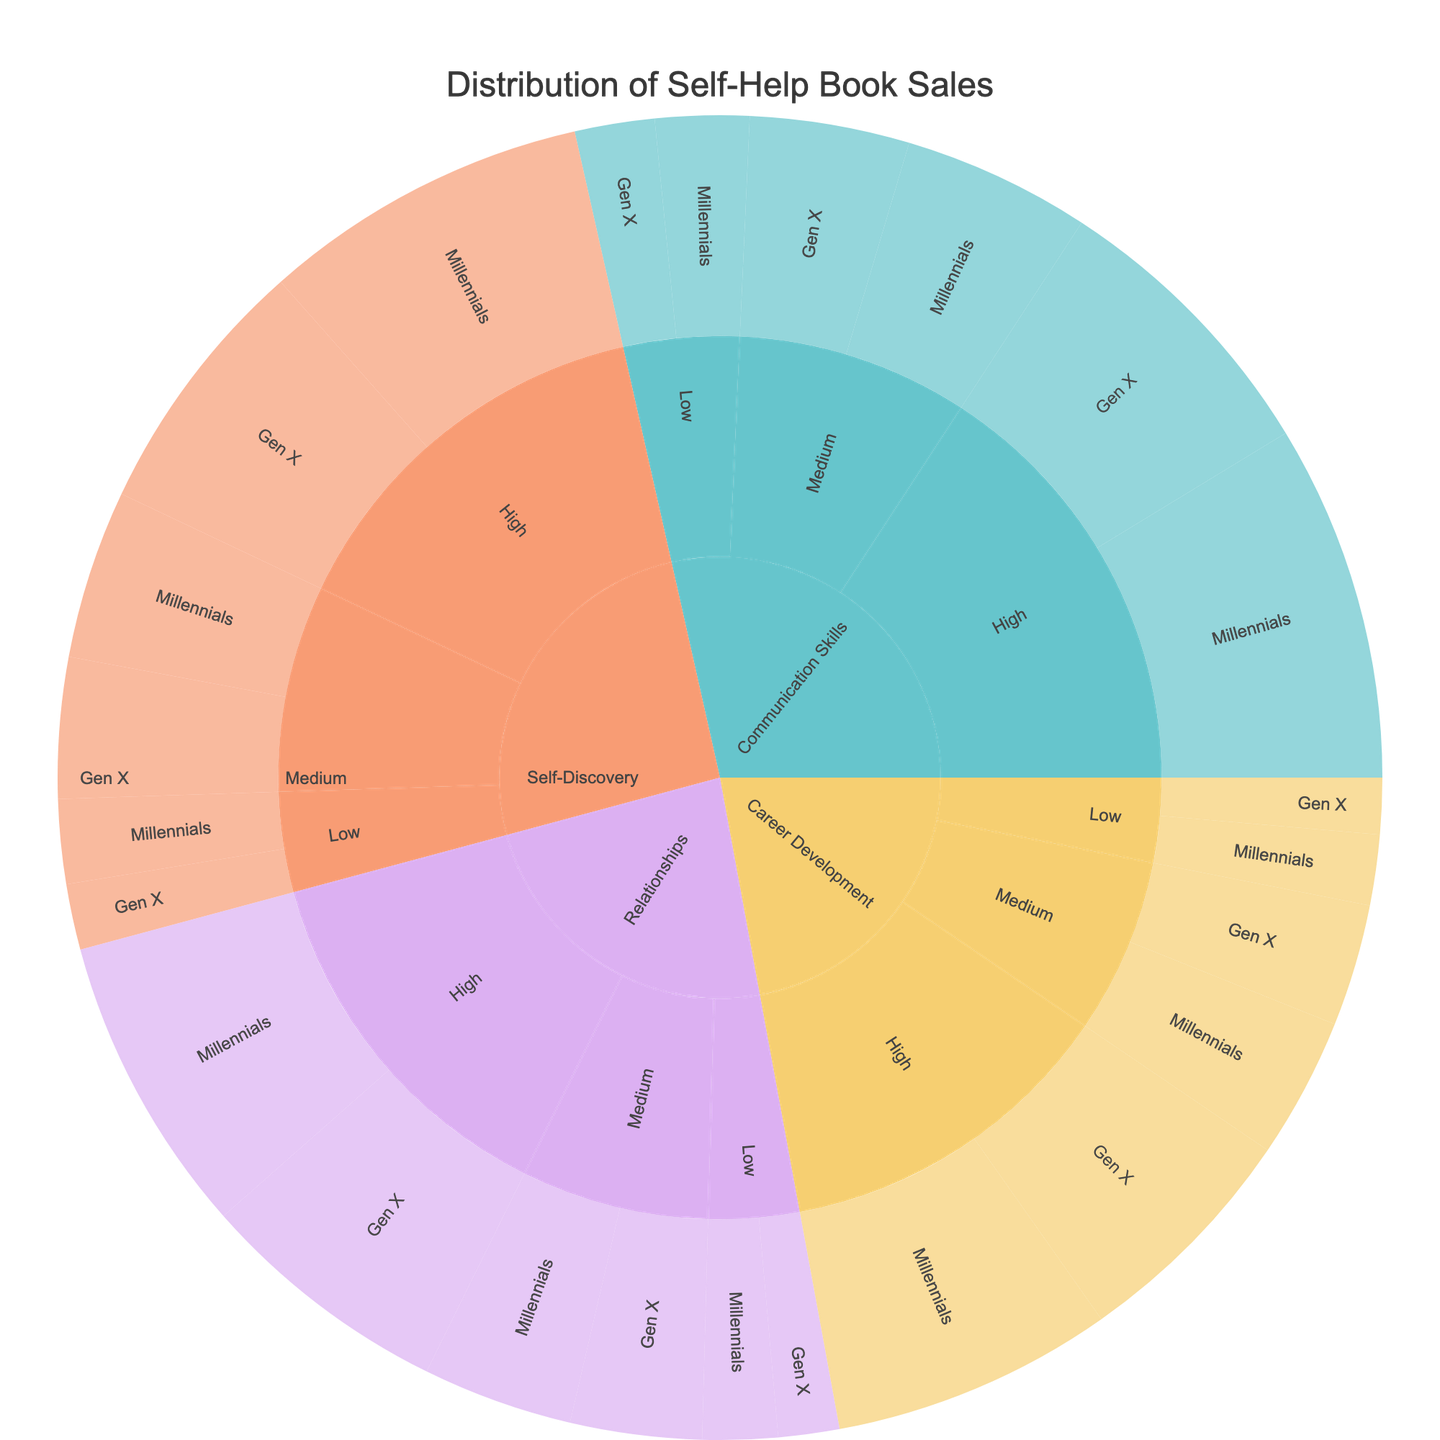what is the genre with the highest sales for Millennials? To identify the genre with the highest sales for Millennials, locate the most extensive segment within each genre and filter by the target audience, which are Millennials. Then, compare the total sales for each genre aimed at Millennials. The largest segment with the highest value will indicate the highest sales.
Answer: Communication Skills How do sales in the Career Development genre compare between High and Medium popularity authors for Gen X? In the Career Development genre, check the segments for High and Medium popularity authors targeting Gen X. Sum the sales for High popularity authors (250,000) and for Medium popularity authors (130,000), and then compare these two sums to determine the difference.
Answer: 120,000 more for High What proportion of total sales does Self-Discovery generate for Gen X? Sum the sales of Self-Discovery books targeting Gen X, which is 280,000 (High authors) + 150,000 (Medium authors) + 70,000 (Low authors) = 500,000. Divide this by the total sales for the entire dataset, calculated across all segments. The dataset's total sales are 4,935,000, deriving proportion as 500,000/4,935,000.
Answer: 10.13% Which target audience has higher sales for Low popularity authors in the Relationships genre, Millennials or Gen X? Compare the sales of Low popularity authors in the Relationships genre segmented by target audience. For Millennials, it's 80,000, and for Gen X, it's 65,000. Determine which number is higher.
Answer: Millennials In which genre do Medium popularity authors receive the lowest sales from Millennials? Examine each genre and target the segment for Medium popularity authors aimed at Millennials. Compare the sales figures across these segments: Self-Discovery (180,000), Relationships (160,000), Career Development (150,000), and Communication Skills (200,000). The lowest figure here identifies the specific genre.
Answer: Career Development What's the difference in total sales between Communication Skills and Career Development for Gen X? First, sum up sales for Communication Skills targeting Gen X: 310,000 (High), 170,000 (Medium), 85,000 (Low) = 565,000. Then sum up sales for Career Development targeting Gen X: 250,000 (High), 130,000 (Medium), 60,000 (Low) = 440,000. Subtract the total for Career Development from the total for Communication Skills.
Answer: 125,000 